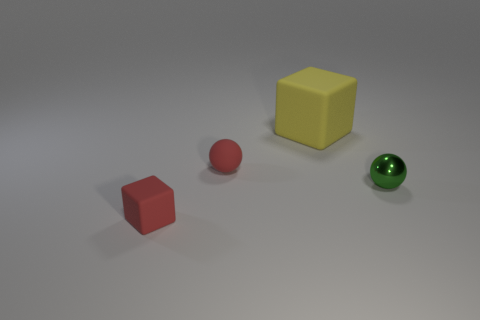Add 1 tiny gray cylinders. How many objects exist? 5 Subtract all big yellow rubber objects. Subtract all rubber spheres. How many objects are left? 2 Add 4 matte things. How many matte things are left? 7 Add 4 small brown rubber things. How many small brown rubber things exist? 4 Subtract 0 purple cylinders. How many objects are left? 4 